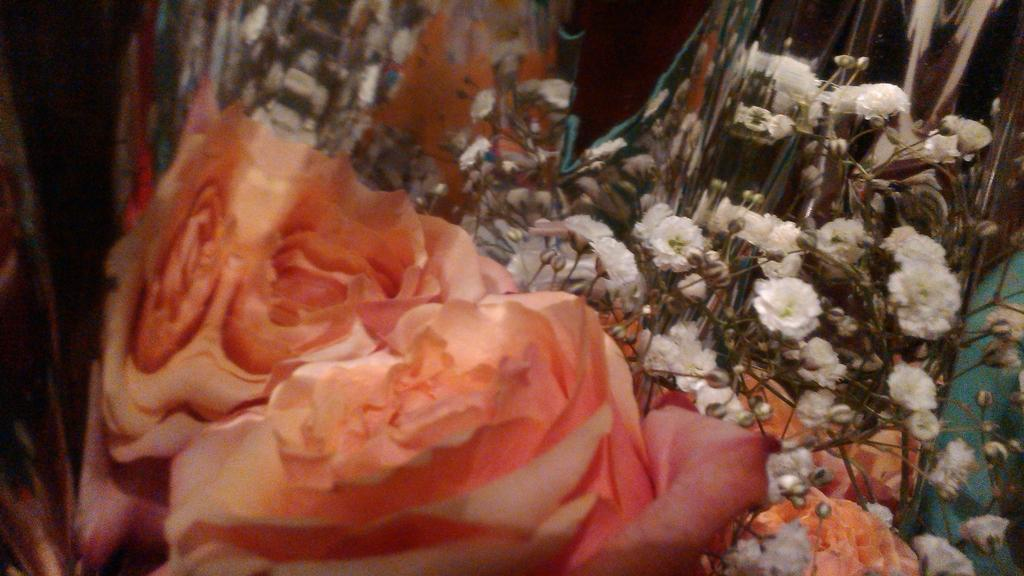What type of plants are in the image? There are flowering plants in the image. Where are the flowering plants located? The flowering plants are on the floor. Can you describe the setting where the flowering plants are located? The image may have been taken in a hall. What type of book is being read by the flowering plants in the image? There is no book present in the image, as it features flowering plants on the floor. What type of meal is being prepared by the flowering plants in the image? There is no meal preparation activity involving the flowering plants in the image. What type of eggnog is being served by the flowering plants in the image? There is no eggnog or any food or drink being served by the flowering plants in the image. 